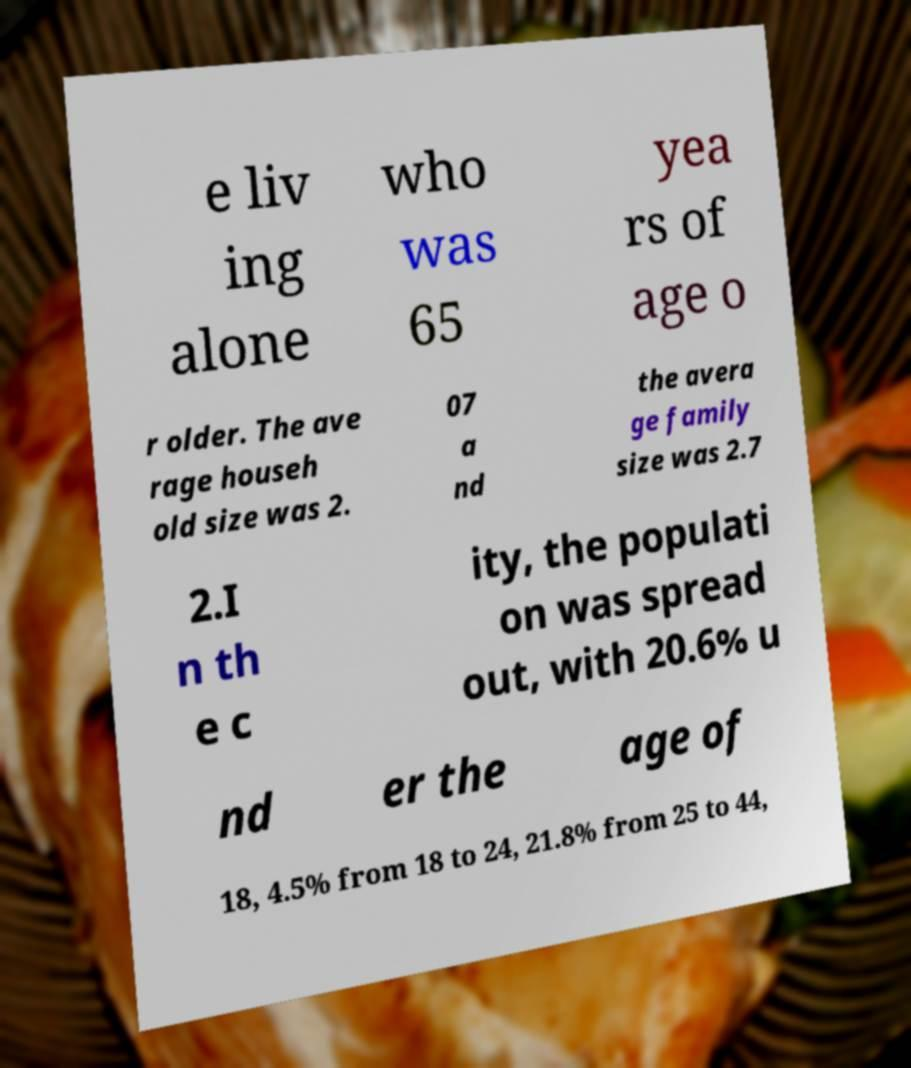Please identify and transcribe the text found in this image. e liv ing alone who was 65 yea rs of age o r older. The ave rage househ old size was 2. 07 a nd the avera ge family size was 2.7 2.I n th e c ity, the populati on was spread out, with 20.6% u nd er the age of 18, 4.5% from 18 to 24, 21.8% from 25 to 44, 